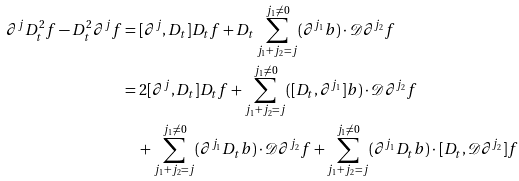<formula> <loc_0><loc_0><loc_500><loc_500>\partial ^ { j } D _ { t } ^ { 2 } f - D _ { t } ^ { 2 } \partial ^ { j } f & = [ \partial ^ { j } , D _ { t } ] D _ { t } f + D _ { t } \sum _ { j _ { 1 } + j _ { 2 } = j } ^ { j _ { 1 } \neq 0 } ( \partial ^ { j _ { 1 } } b ) \cdot \mathcal { D } \partial ^ { j _ { 2 } } f \\ & = 2 [ \partial ^ { j } , D _ { t } ] D _ { t } f + \sum _ { j _ { 1 } + j _ { 2 } = j } ^ { j _ { 1 } \neq 0 } ( [ D _ { t } , \partial ^ { j _ { 1 } } ] b ) \cdot \mathcal { D } \partial ^ { j _ { 2 } } f \\ & \quad + \sum _ { j _ { 1 } + j _ { 2 } = j } ^ { j _ { 1 } \neq 0 } ( \partial ^ { j _ { 1 } } D _ { t } b ) \cdot \mathcal { D } \partial ^ { j _ { 2 } } f + \sum _ { j _ { 1 } + j _ { 2 } = j } ^ { j _ { 1 } \neq 0 } ( \partial ^ { j _ { 1 } } D _ { t } b ) \cdot [ D _ { t } , \mathcal { D } \partial ^ { j _ { 2 } } ] f</formula> 